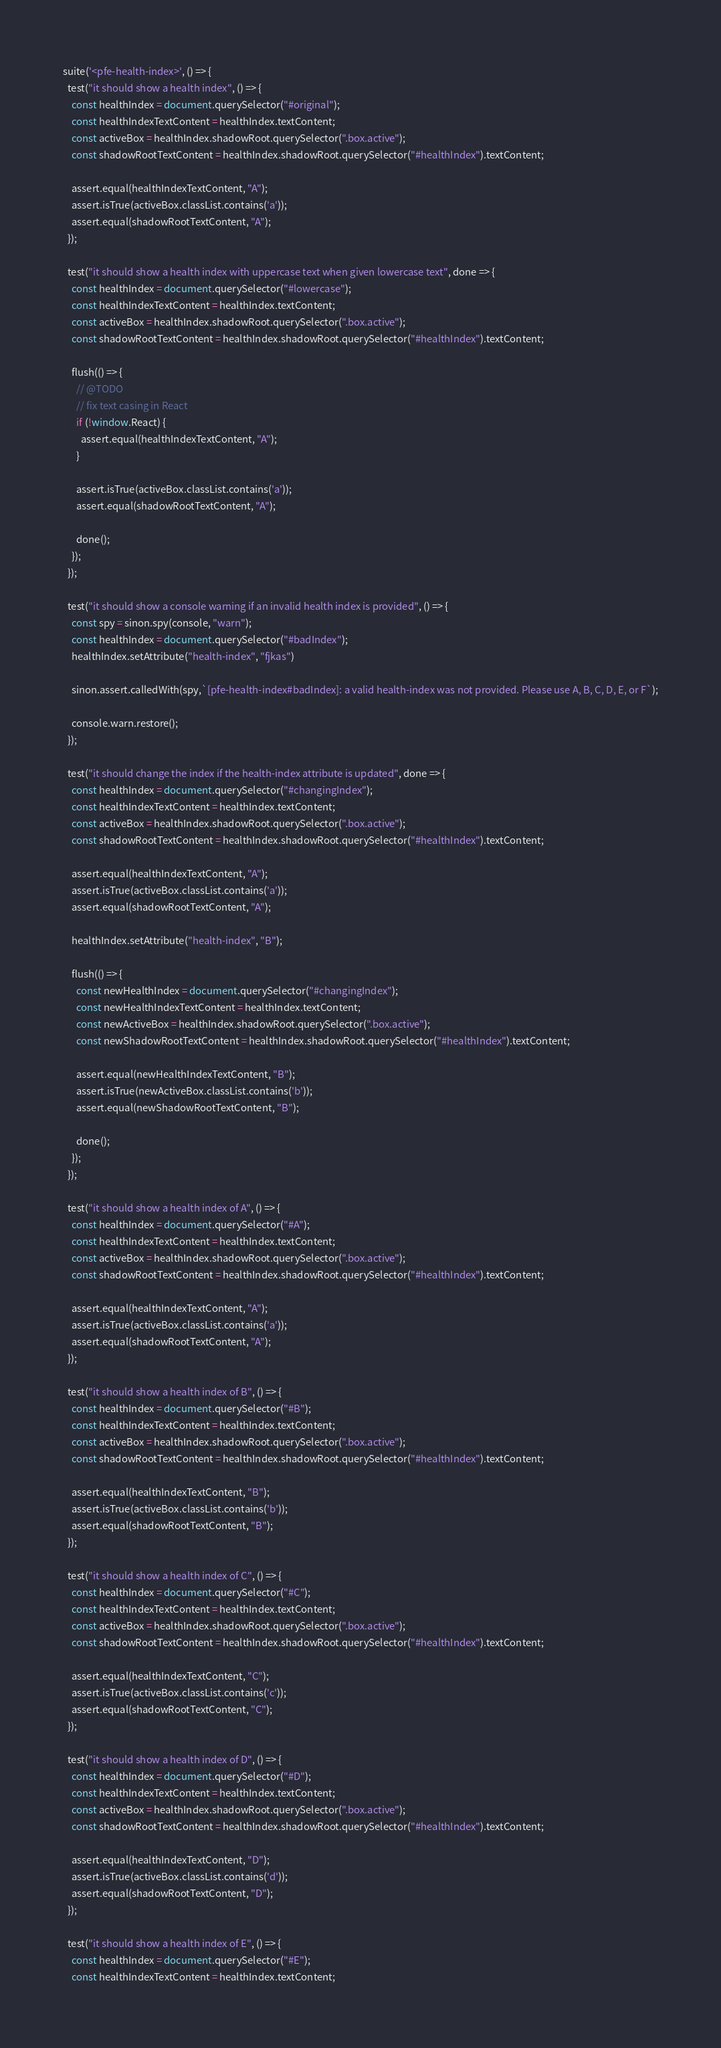Convert code to text. <code><loc_0><loc_0><loc_500><loc_500><_JavaScript_>suite('<pfe-health-index>', () => {
  test("it should show a health index", () => {
    const healthIndex = document.querySelector("#original");
    const healthIndexTextContent = healthIndex.textContent;
    const activeBox = healthIndex.shadowRoot.querySelector(".box.active");
    const shadowRootTextContent = healthIndex.shadowRoot.querySelector("#healthIndex").textContent;

    assert.equal(healthIndexTextContent, "A");
    assert.isTrue(activeBox.classList.contains('a'));
    assert.equal(shadowRootTextContent, "A");
  });

  test("it should show a health index with uppercase text when given lowercase text", done => {
    const healthIndex = document.querySelector("#lowercase");
    const healthIndexTextContent = healthIndex.textContent;
    const activeBox = healthIndex.shadowRoot.querySelector(".box.active");
    const shadowRootTextContent = healthIndex.shadowRoot.querySelector("#healthIndex").textContent;

    flush(() => {
      // @TODO
      // fix text casing in React
      if (!window.React) {
        assert.equal(healthIndexTextContent, "A");
      }

      assert.isTrue(activeBox.classList.contains('a'));
      assert.equal(shadowRootTextContent, "A");

      done();
    });
  });

  test("it should show a console warning if an invalid health index is provided", () => {
    const spy = sinon.spy(console, "warn");
    const healthIndex = document.querySelector("#badIndex");
    healthIndex.setAttribute("health-index", "fjkas")

    sinon.assert.calledWith(spy,`[pfe-health-index#badIndex]: a valid health-index was not provided. Please use A, B, C, D, E, or F`);

    console.warn.restore();
  });

  test("it should change the index if the health-index attribute is updated", done => {
    const healthIndex = document.querySelector("#changingIndex");
    const healthIndexTextContent = healthIndex.textContent;
    const activeBox = healthIndex.shadowRoot.querySelector(".box.active");
    const shadowRootTextContent = healthIndex.shadowRoot.querySelector("#healthIndex").textContent;

    assert.equal(healthIndexTextContent, "A");
    assert.isTrue(activeBox.classList.contains('a'));
    assert.equal(shadowRootTextContent, "A");

    healthIndex.setAttribute("health-index", "B");

    flush(() => {
      const newHealthIndex = document.querySelector("#changingIndex");
      const newHealthIndexTextContent = healthIndex.textContent;
      const newActiveBox = healthIndex.shadowRoot.querySelector(".box.active");
      const newShadowRootTextContent = healthIndex.shadowRoot.querySelector("#healthIndex").textContent;

      assert.equal(newHealthIndexTextContent, "B");
      assert.isTrue(newActiveBox.classList.contains('b'));
      assert.equal(newShadowRootTextContent, "B");

      done();
    });
  });

  test("it should show a health index of A", () => {
    const healthIndex = document.querySelector("#A");
    const healthIndexTextContent = healthIndex.textContent;
    const activeBox = healthIndex.shadowRoot.querySelector(".box.active");
    const shadowRootTextContent = healthIndex.shadowRoot.querySelector("#healthIndex").textContent;

    assert.equal(healthIndexTextContent, "A");
    assert.isTrue(activeBox.classList.contains('a'));
    assert.equal(shadowRootTextContent, "A");
  });

  test("it should show a health index of B", () => {
    const healthIndex = document.querySelector("#B");
    const healthIndexTextContent = healthIndex.textContent;
    const activeBox = healthIndex.shadowRoot.querySelector(".box.active");
    const shadowRootTextContent = healthIndex.shadowRoot.querySelector("#healthIndex").textContent;

    assert.equal(healthIndexTextContent, "B");
    assert.isTrue(activeBox.classList.contains('b'));
    assert.equal(shadowRootTextContent, "B");
  });

  test("it should show a health index of C", () => {
    const healthIndex = document.querySelector("#C");
    const healthIndexTextContent = healthIndex.textContent;
    const activeBox = healthIndex.shadowRoot.querySelector(".box.active");
    const shadowRootTextContent = healthIndex.shadowRoot.querySelector("#healthIndex").textContent;

    assert.equal(healthIndexTextContent, "C");
    assert.isTrue(activeBox.classList.contains('c'));
    assert.equal(shadowRootTextContent, "C");
  });

  test("it should show a health index of D", () => {
    const healthIndex = document.querySelector("#D");
    const healthIndexTextContent = healthIndex.textContent;
    const activeBox = healthIndex.shadowRoot.querySelector(".box.active");
    const shadowRootTextContent = healthIndex.shadowRoot.querySelector("#healthIndex").textContent;

    assert.equal(healthIndexTextContent, "D");
    assert.isTrue(activeBox.classList.contains('d'));
    assert.equal(shadowRootTextContent, "D");
  });

  test("it should show a health index of E", () => {
    const healthIndex = document.querySelector("#E");
    const healthIndexTextContent = healthIndex.textContent;</code> 